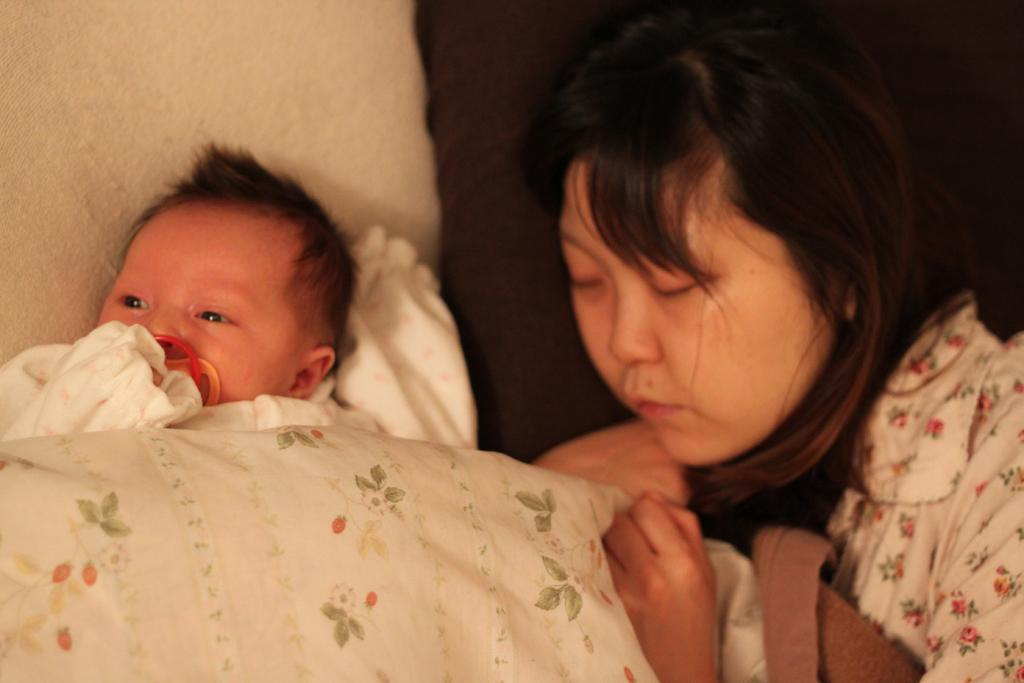What is the woman doing in the image? The woman is lying on the bed in the image. What is covering the bed? There is a blanket and cloth on the bed. Who else is on the bed? There is a baby boy on the bed. What might be used for support or comfort while lying on the bed? There are pillows at the top of the bed. What time of day is it in the image, and where is the flock of birds? The time of day is not mentioned in the image, and there is no flock of birds present. What is the baby boy using to poke the stick into the wall? There is no stick present in the image. 